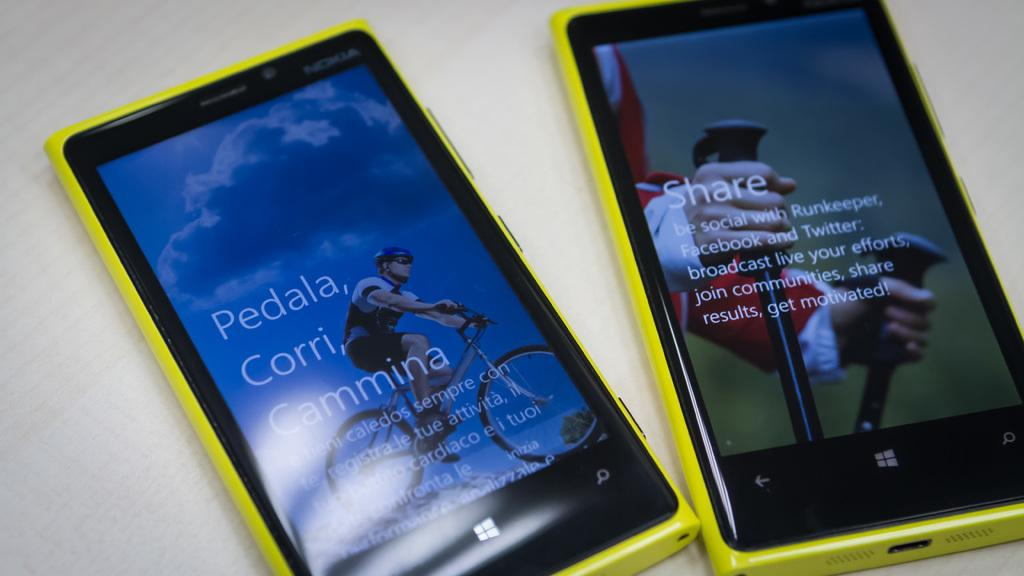Provide a one-sentence caption for the provided image. Two phones that both have yellow exteriors and are Window phones. 